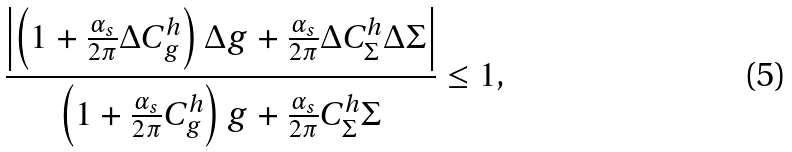Convert formula to latex. <formula><loc_0><loc_0><loc_500><loc_500>\frac { \left | \left ( 1 + \frac { \alpha _ { s } } { 2 \pi } \Delta C ^ { h } _ { g } \right ) \Delta g + \frac { \alpha _ { s } } { 2 \pi } \Delta C ^ { h } _ { \Sigma } \Delta \Sigma \right | } { \left ( 1 + \frac { \alpha _ { s } } { 2 \pi } C ^ { h } _ { g } \right ) g + \frac { \alpha _ { s } } { 2 \pi } C ^ { h } _ { \Sigma } \Sigma } \leq 1 ,</formula> 